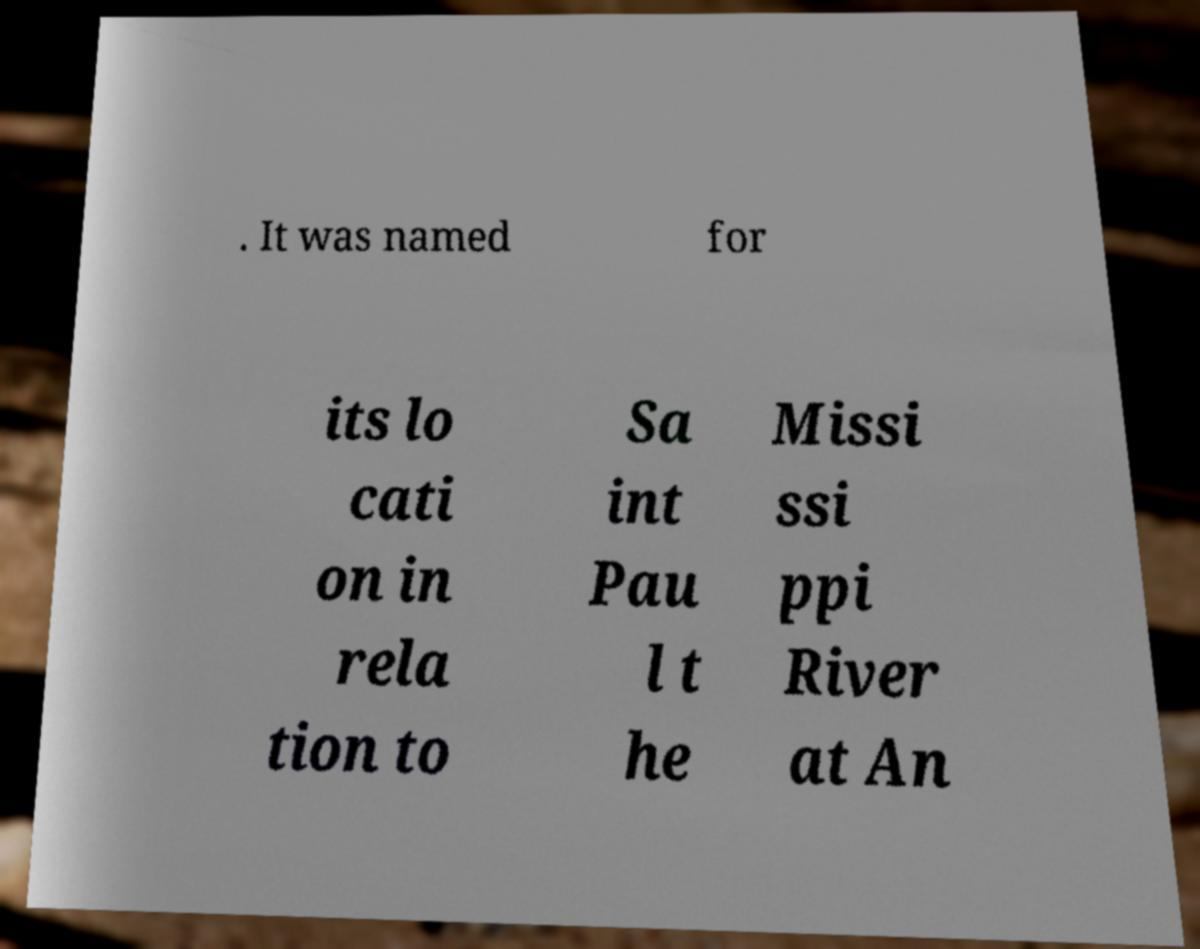Can you accurately transcribe the text from the provided image for me? . It was named for its lo cati on in rela tion to Sa int Pau l t he Missi ssi ppi River at An 